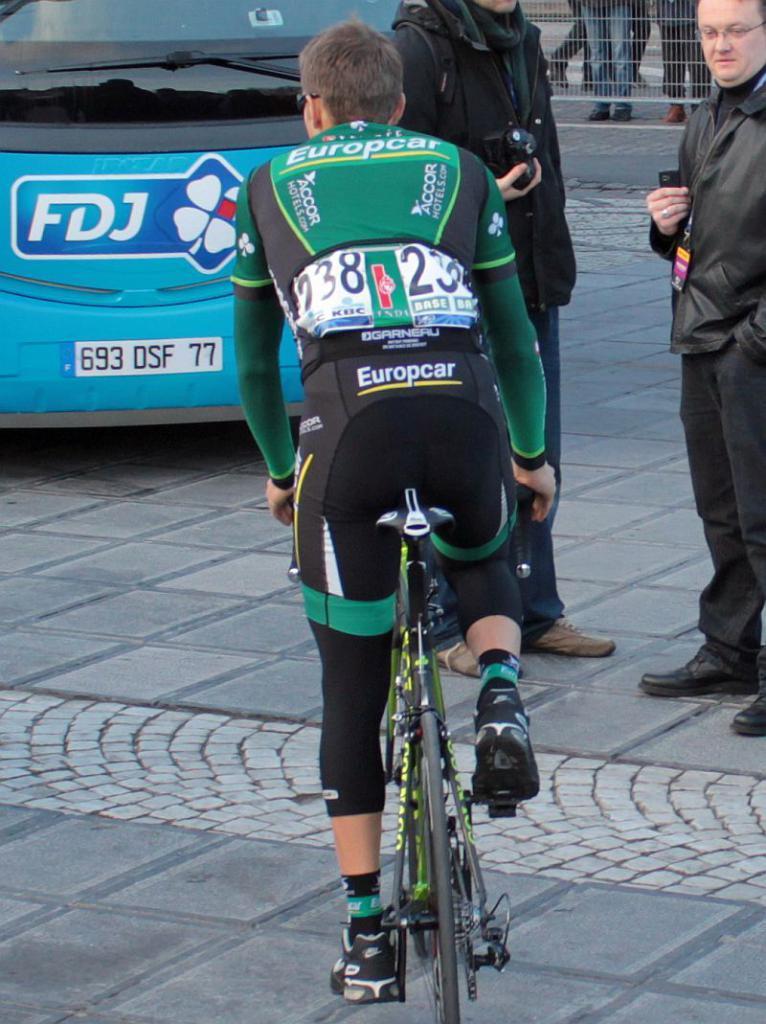Can you describe this image briefly? There is a man riding bicycle on road and behind him there is a car and few man standing holding camera. 